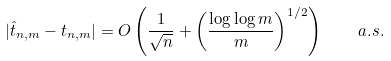<formula> <loc_0><loc_0><loc_500><loc_500>| \hat { t } _ { n , m } - t _ { n , m } | = O \left ( \frac { 1 } { \sqrt { n } } + \left ( \frac { \log \log m } { m } \right ) ^ { 1 / 2 } \right ) \quad a . s .</formula> 